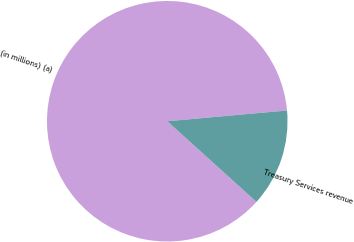<chart> <loc_0><loc_0><loc_500><loc_500><pie_chart><fcel>(in millions) (a)<fcel>Treasury Services revenue<nl><fcel>86.87%<fcel>13.13%<nl></chart> 